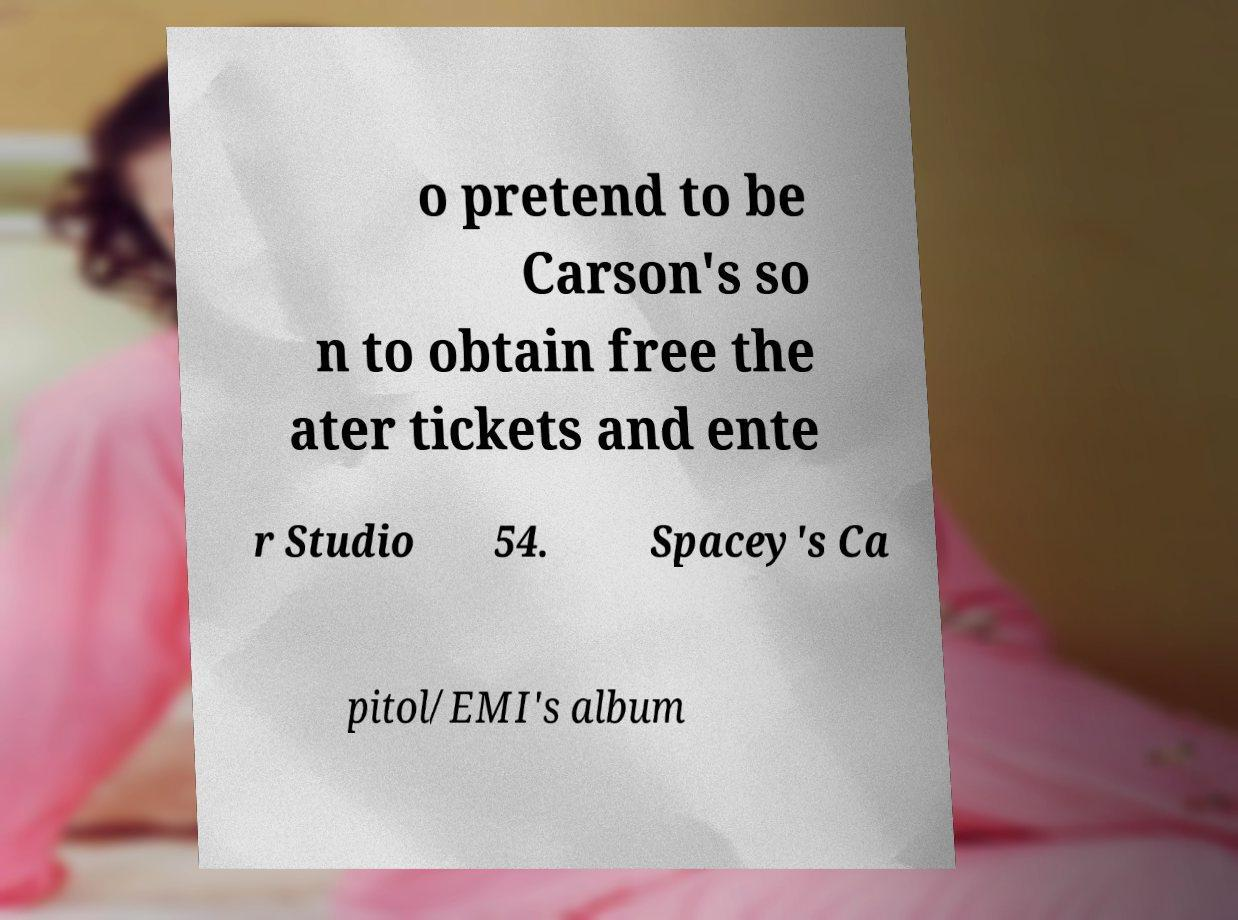Please read and relay the text visible in this image. What does it say? o pretend to be Carson's so n to obtain free the ater tickets and ente r Studio 54. Spacey's Ca pitol/EMI's album 